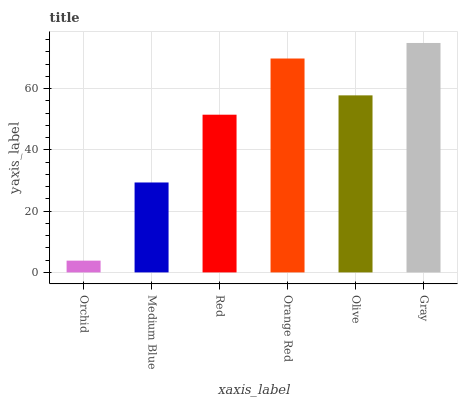Is Orchid the minimum?
Answer yes or no. Yes. Is Gray the maximum?
Answer yes or no. Yes. Is Medium Blue the minimum?
Answer yes or no. No. Is Medium Blue the maximum?
Answer yes or no. No. Is Medium Blue greater than Orchid?
Answer yes or no. Yes. Is Orchid less than Medium Blue?
Answer yes or no. Yes. Is Orchid greater than Medium Blue?
Answer yes or no. No. Is Medium Blue less than Orchid?
Answer yes or no. No. Is Olive the high median?
Answer yes or no. Yes. Is Red the low median?
Answer yes or no. Yes. Is Orange Red the high median?
Answer yes or no. No. Is Orange Red the low median?
Answer yes or no. No. 